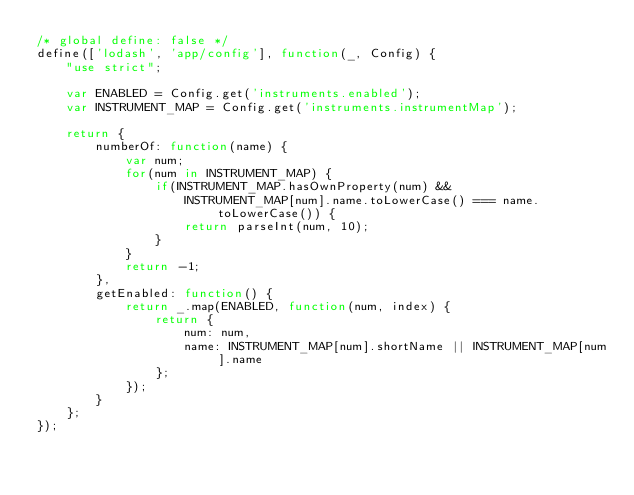Convert code to text. <code><loc_0><loc_0><loc_500><loc_500><_JavaScript_>/* global define: false */
define(['lodash', 'app/config'], function(_, Config) {
	"use strict";

	var ENABLED = Config.get('instruments.enabled');
	var INSTRUMENT_MAP = Config.get('instruments.instrumentMap');

	return {
		numberOf: function(name) {
			var num;
			for(num in INSTRUMENT_MAP) {
				if(INSTRUMENT_MAP.hasOwnProperty(num) && 
					INSTRUMENT_MAP[num].name.toLowerCase() === name.toLowerCase()) {
					return parseInt(num, 10);
				}
			}
			return -1;
		},
		getEnabled: function() {
			return _.map(ENABLED, function(num, index) {
				return { 
					num: num, 
					name: INSTRUMENT_MAP[num].shortName || INSTRUMENT_MAP[num].name
				};
			});
		}
	};
});
</code> 